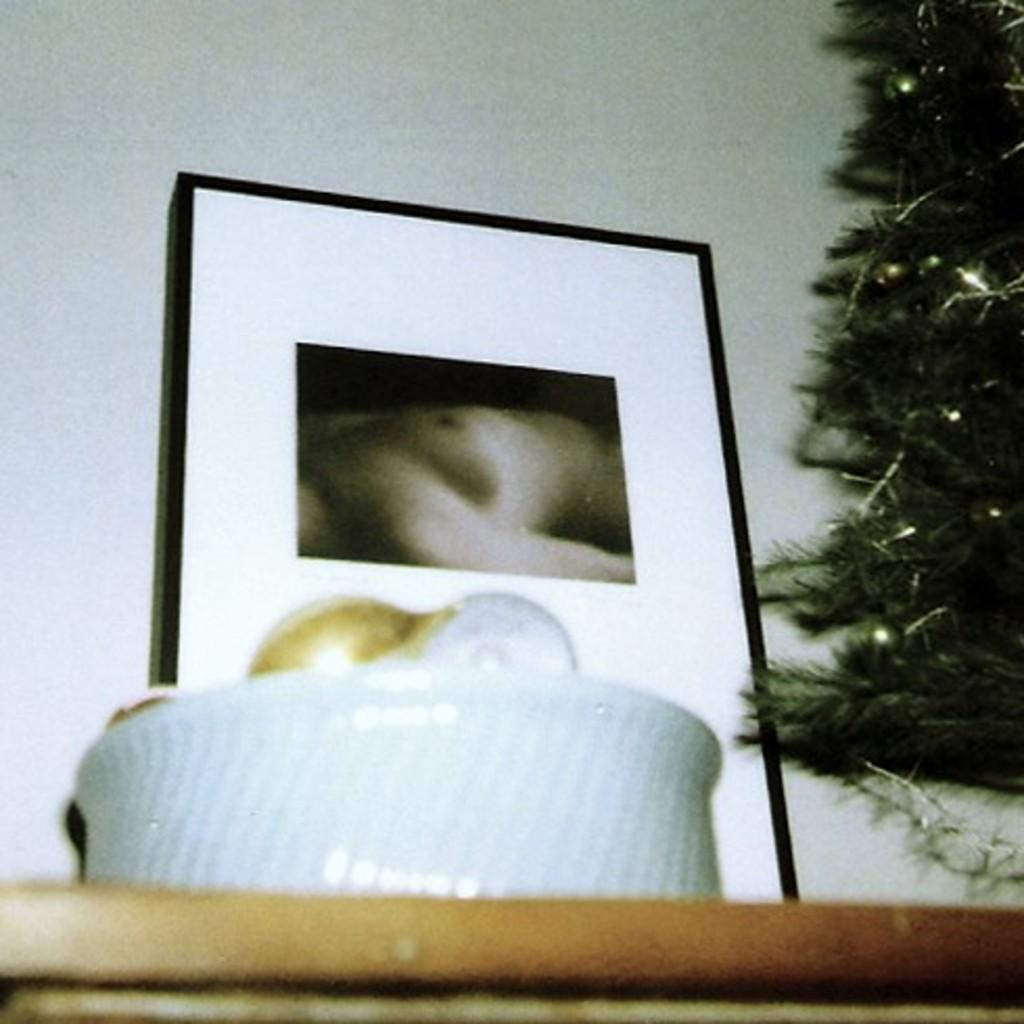What is located in the foreground of the image? There is a bowl in the foreground of the image. Where is the bowl placed? The bowl is placed on a table. What can be seen on the right side of the image? There is a tree on the right side of the image. What is visible in the background of the image? There is a photo frame in the background of the image. What is the price of the rainstorm in the image? There is no rainstorm present in the image, so it is not possible to determine its price. 